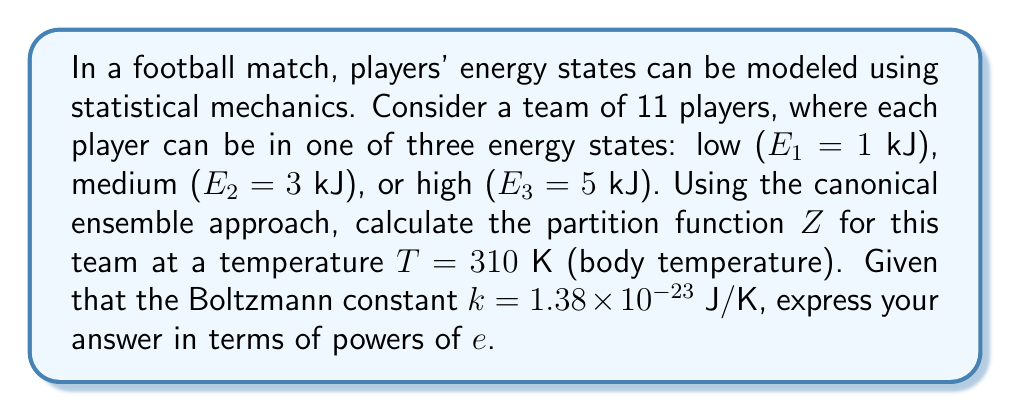Can you solve this math problem? To solve this problem, we'll use the canonical ensemble approach:

1) The partition function Z is given by:
   $$Z = \sum_{i} g_i e^{-\beta E_i}$$
   where $g_i$ is the degeneracy of state i, $\beta = \frac{1}{kT}$, and $E_i$ is the energy of state i.

2) Calculate $\beta$:
   $$\beta = \frac{1}{kT} = \frac{1}{(1.38 \times 10^{-23} \text{ J/K})(310 \text{ K})} = 2.33 \times 10^{20} \text{ J}^{-1}$$

3) Convert energies to Joules:
   $E_1 = 1 \text{ kJ} = 1000 \text{ J}$
   $E_2 = 3 \text{ kJ} = 3000 \text{ J}$
   $E_3 = 5 \text{ kJ} = 5000 \text{ J}$

4) Calculate the Boltzmann factors:
   $$e^{-\beta E_1} = e^{-(2.33 \times 10^{20})(1000)} = e^{-2.33 \times 10^{23}}$$
   $$e^{-\beta E_2} = e^{-(2.33 \times 10^{20})(3000)} = e^{-6.99 \times 10^{23}}$$
   $$e^{-\beta E_3} = e^{-(2.33 \times 10^{20})(5000)} = e^{-1.17 \times 10^{24}}$$

5) For each player, the partition function is:
   $$Z_{\text{player}} = e^{-2.33 \times 10^{23}} + e^{-6.99 \times 10^{23}} + e^{-1.17 \times 10^{24}}$$

6) For the entire team of 11 players, the total partition function is:
   $$Z = (Z_{\text{player}})^{11} = (e^{-2.33 \times 10^{23}} + e^{-6.99 \times 10^{23}} + e^{-1.17 \times 10^{24}})^{11}$$

This is the final expression for the partition function Z.
Answer: $$(e^{-2.33 \times 10^{23}} + e^{-6.99 \times 10^{23}} + e^{-1.17 \times 10^{24}})^{11}$$ 